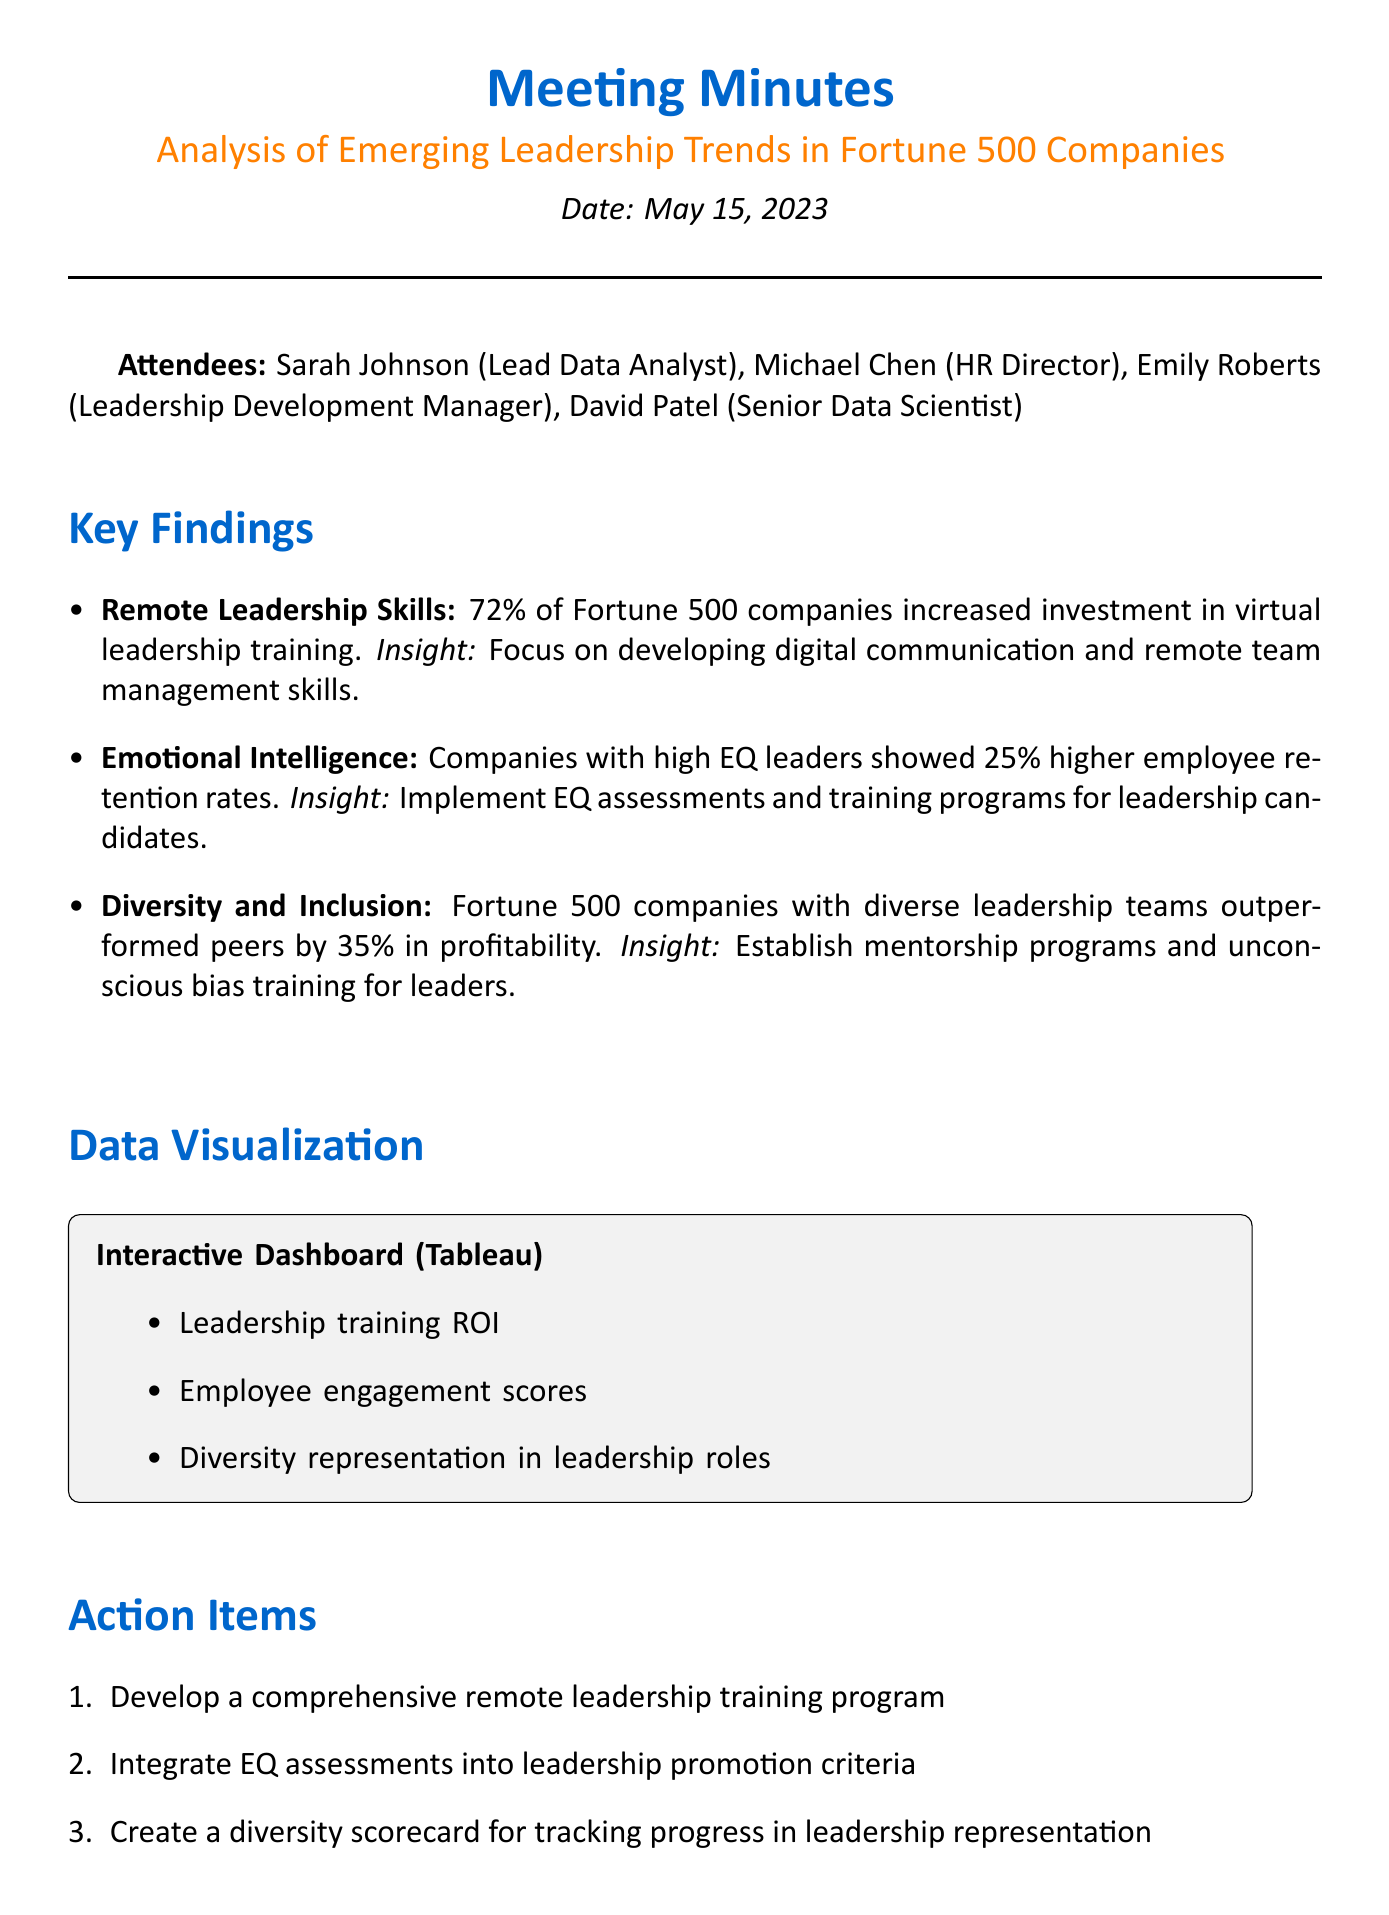What is the date of the meeting? The date of the meeting is mentioned at the top of the document as May 15, 2023.
Answer: May 15, 2023 Who is the HR Director? The attendees list includes Michael Chen, who is the HR Director.
Answer: Michael Chen What percentage of companies increased investment in virtual leadership training? The key finding states that 72% of Fortune 500 companies increased investment in virtual leadership training.
Answer: 72% What is the insight associated with Emotional Intelligence? The document indicates the insight regarding Emotional Intelligence is to implement EQ assessments and training programs for leadership candidates.
Answer: Implement EQ assessments and training programs for leadership candidates Which tool is used for data visualization? The data visualization section specifies that Tableau is the tool used for the interactive dashboard.
Answer: Tableau What is one action item listed in the meeting minutes? The action items include developing a comprehensive remote leadership training program, among others.
Answer: Develop a comprehensive remote leadership training program What is the relationship between diverse leadership teams and profitability? The key finding states that Fortune 500 companies with diverse leadership teams outperformed peers by 35% in profitability.
Answer: 35% What is scheduled for the next steps concerning leadership trends? The next steps include scheduling a quarterly review of leadership trends and their impact on company performance.
Answer: Schedule quarterly review of leadership trends and their impact on company performance 